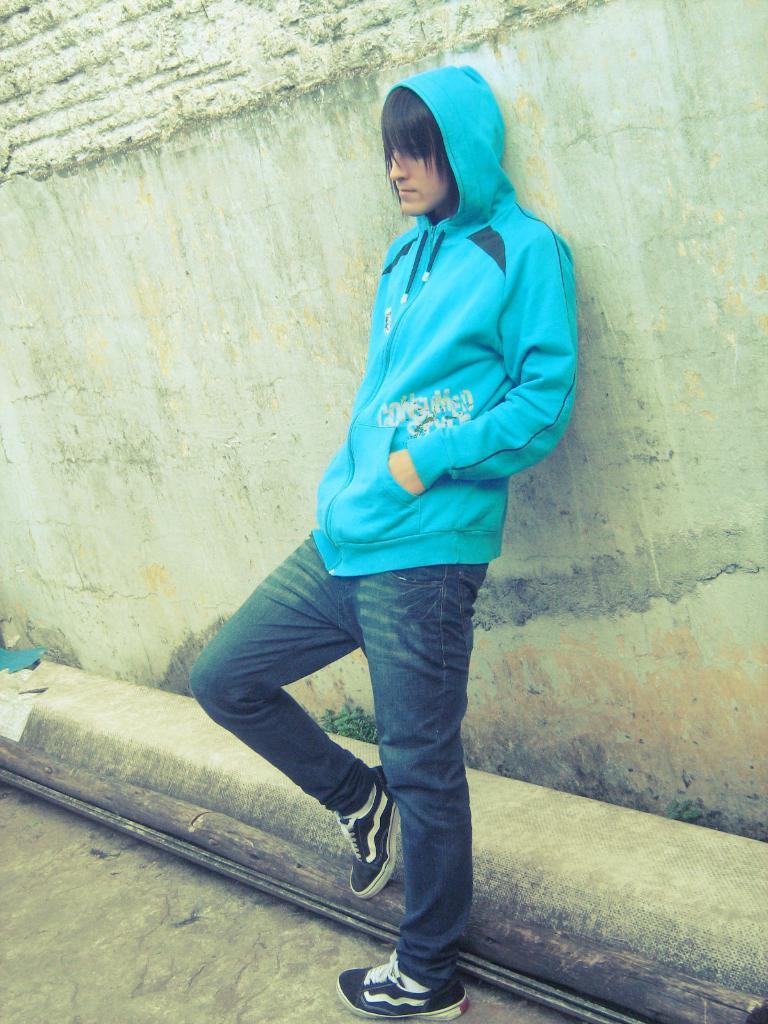In one or two sentences, can you explain what this image depicts? In this picture I can see there is a man standing and he is wearing a blue hoodie and wearing black shoes and in the backdrop there is a wall. 